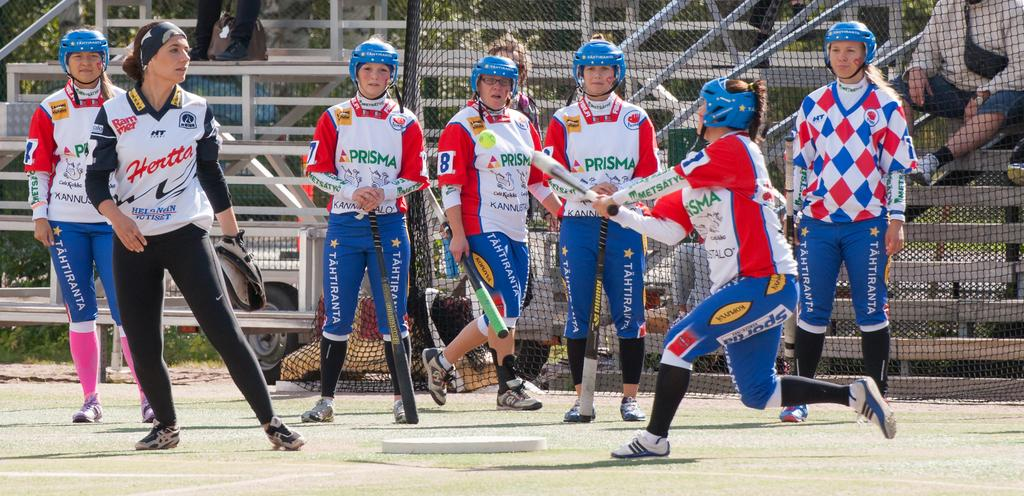<image>
Write a terse but informative summary of the picture. A female baseball team called Prisma are playing a game on the field. 